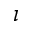<formula> <loc_0><loc_0><loc_500><loc_500>\iota</formula> 